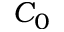Convert formula to latex. <formula><loc_0><loc_0><loc_500><loc_500>C _ { 0 }</formula> 